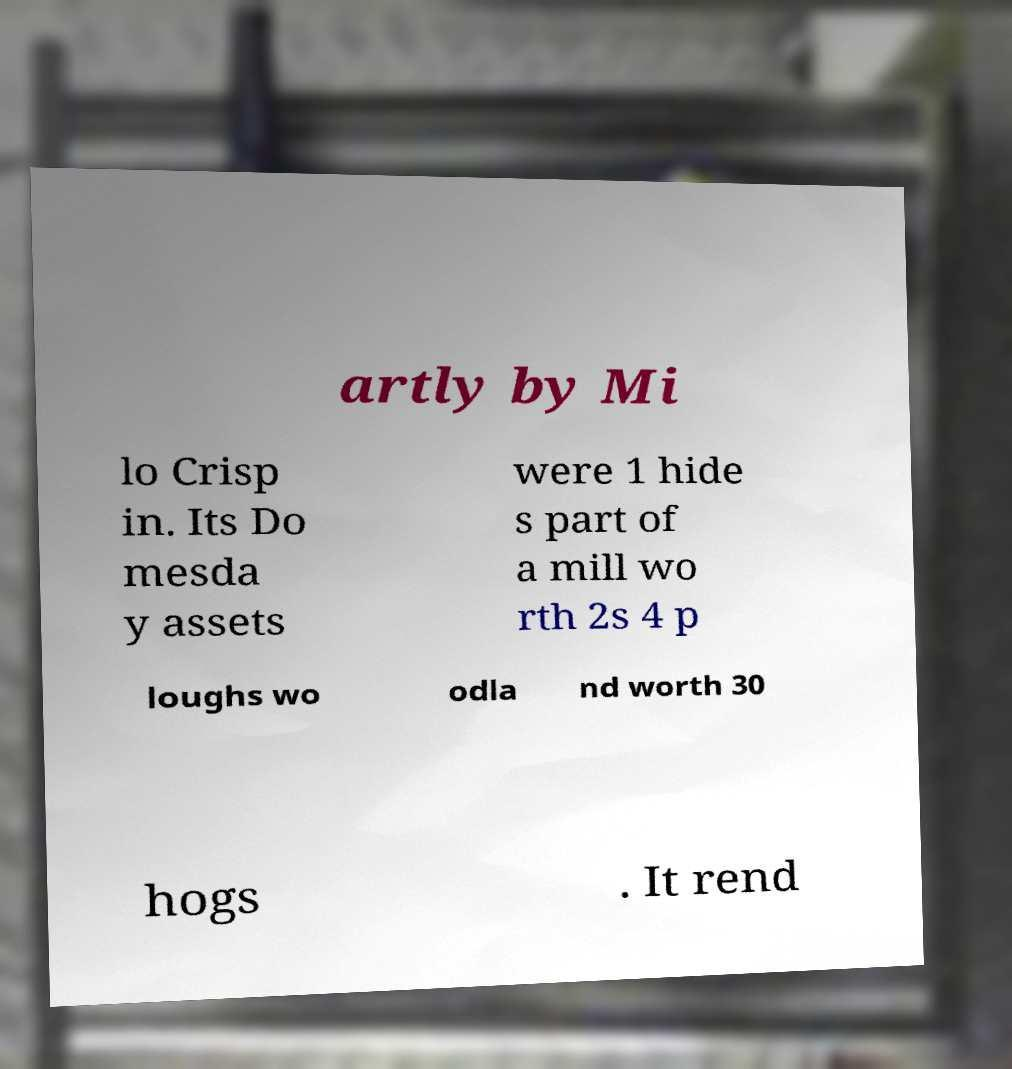For documentation purposes, I need the text within this image transcribed. Could you provide that? artly by Mi lo Crisp in. Its Do mesda y assets were 1 hide s part of a mill wo rth 2s 4 p loughs wo odla nd worth 30 hogs . It rend 